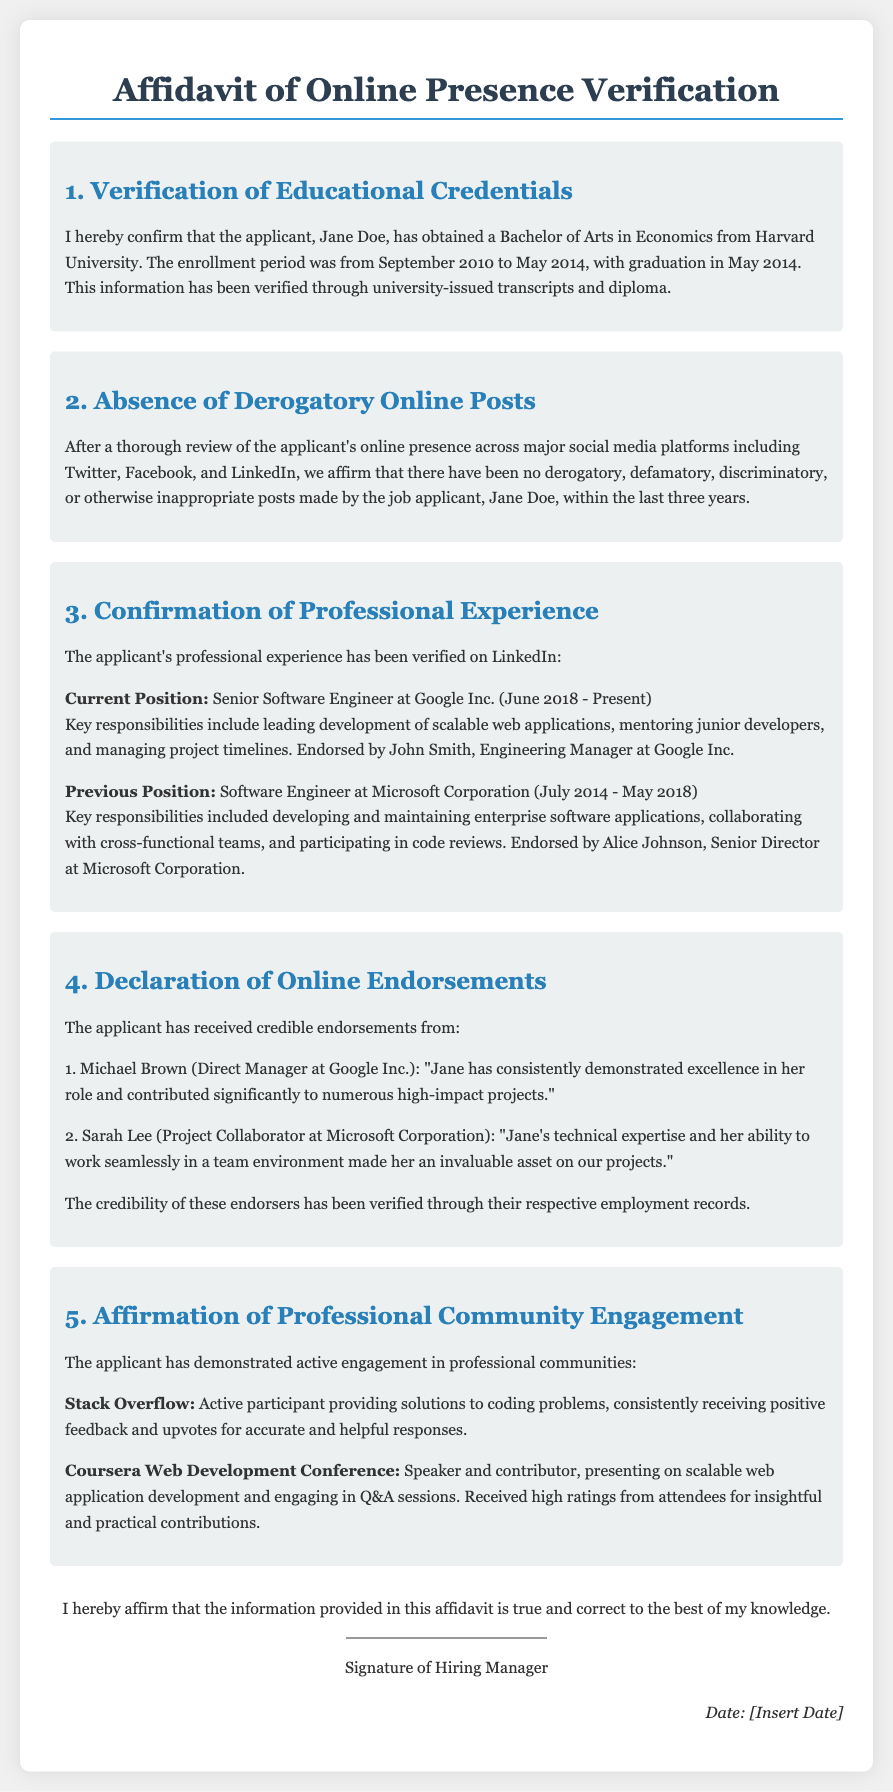What degree did the applicant obtain? The applicant obtained a Bachelor of Arts in Economics, which is specified in the educational credentials section.
Answer: Bachelor of Arts in Economics What was the enrollment period at Harvard University? The enrollment period for the applicant at Harvard University is from September 2010 to May 2014.
Answer: September 2010 to May 2014 Who is the current employer of the applicant? The current employer of the applicant is mentioned in the professional experience section, which states the applicant works at Google Inc.
Answer: Google Inc How long did the applicant work at Microsoft Corporation? The document specifies the employment dates at Microsoft Corporation, which are from July 2014 to May 2018, allowing us to determine the duration of employment.
Answer: 4 years Which online community did the applicant engage with as a speaker? The document states that the applicant was a speaker at the Coursera Web Development Conference.
Answer: Coursera Web Development Conference What type of feedback did the applicant receive for participation in Stack Overflow? Feedback received on Stack Overflow is mentioned as positive feedback and upvotes for accurate and helpful responses.
Answer: Positive feedback and upvotes Who endorsed the applicant at Google Inc.? The document lists Michael Brown as the direct manager who endorsed the applicant at Google Inc.
Answer: Michael Brown How many years of absence of derogatory posts is affirmed in the document? The document specifically notes the absence of derogatory posts made by the applicant within the last three years.
Answer: Three years 